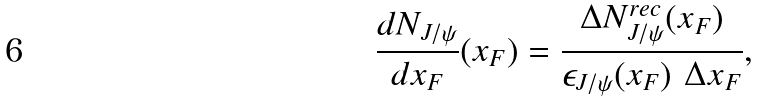<formula> <loc_0><loc_0><loc_500><loc_500>\frac { d N _ { J / \psi } } { d x _ { F } } ( x _ { F } ) = \frac { \Delta N ^ { r e c } _ { J / \psi } ( x _ { F } ) } { \epsilon _ { J / \psi } ( x _ { F } ) \ \Delta x _ { F } } ,</formula> 